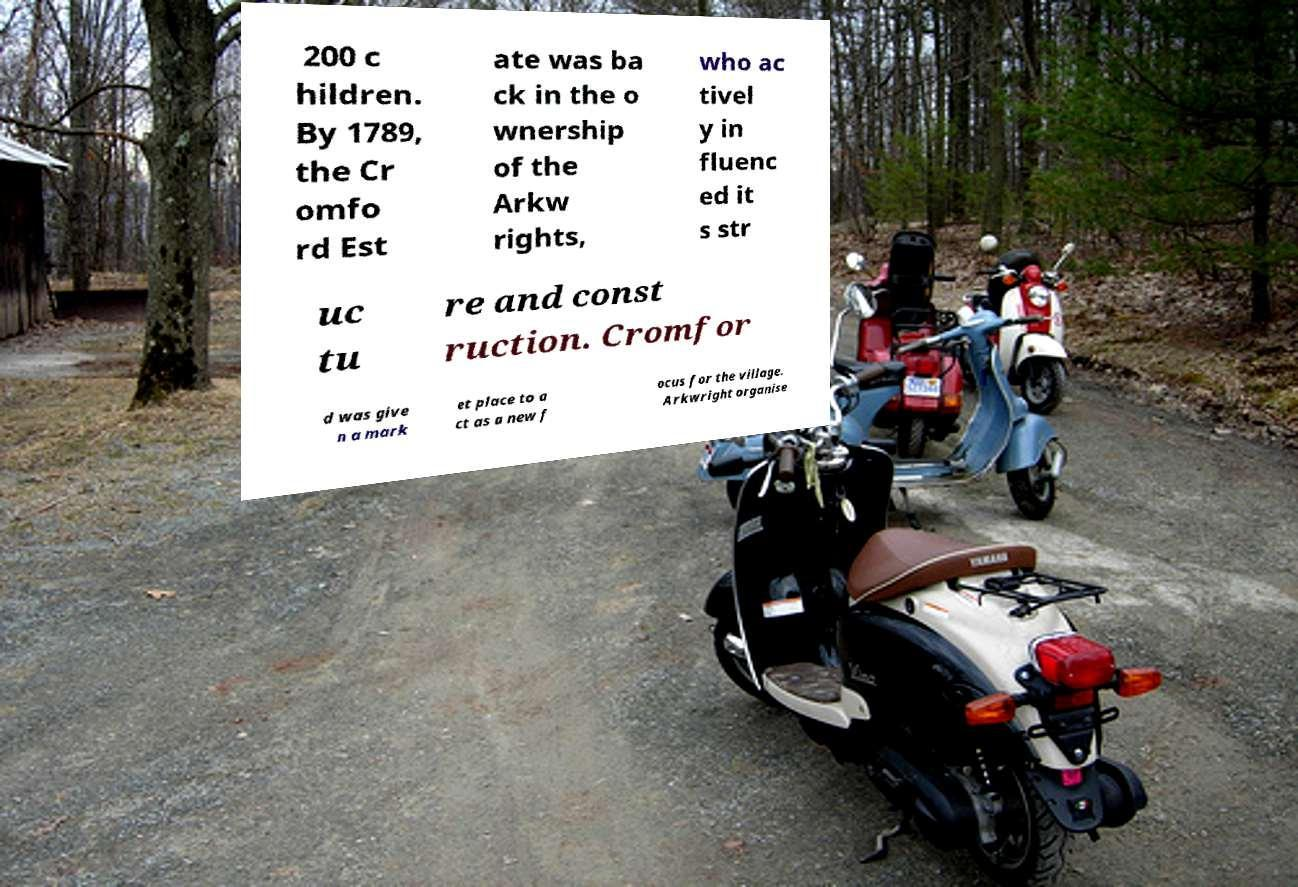There's text embedded in this image that I need extracted. Can you transcribe it verbatim? 200 c hildren. By 1789, the Cr omfo rd Est ate was ba ck in the o wnership of the Arkw rights, who ac tivel y in fluenc ed it s str uc tu re and const ruction. Cromfor d was give n a mark et place to a ct as a new f ocus for the village. Arkwright organise 